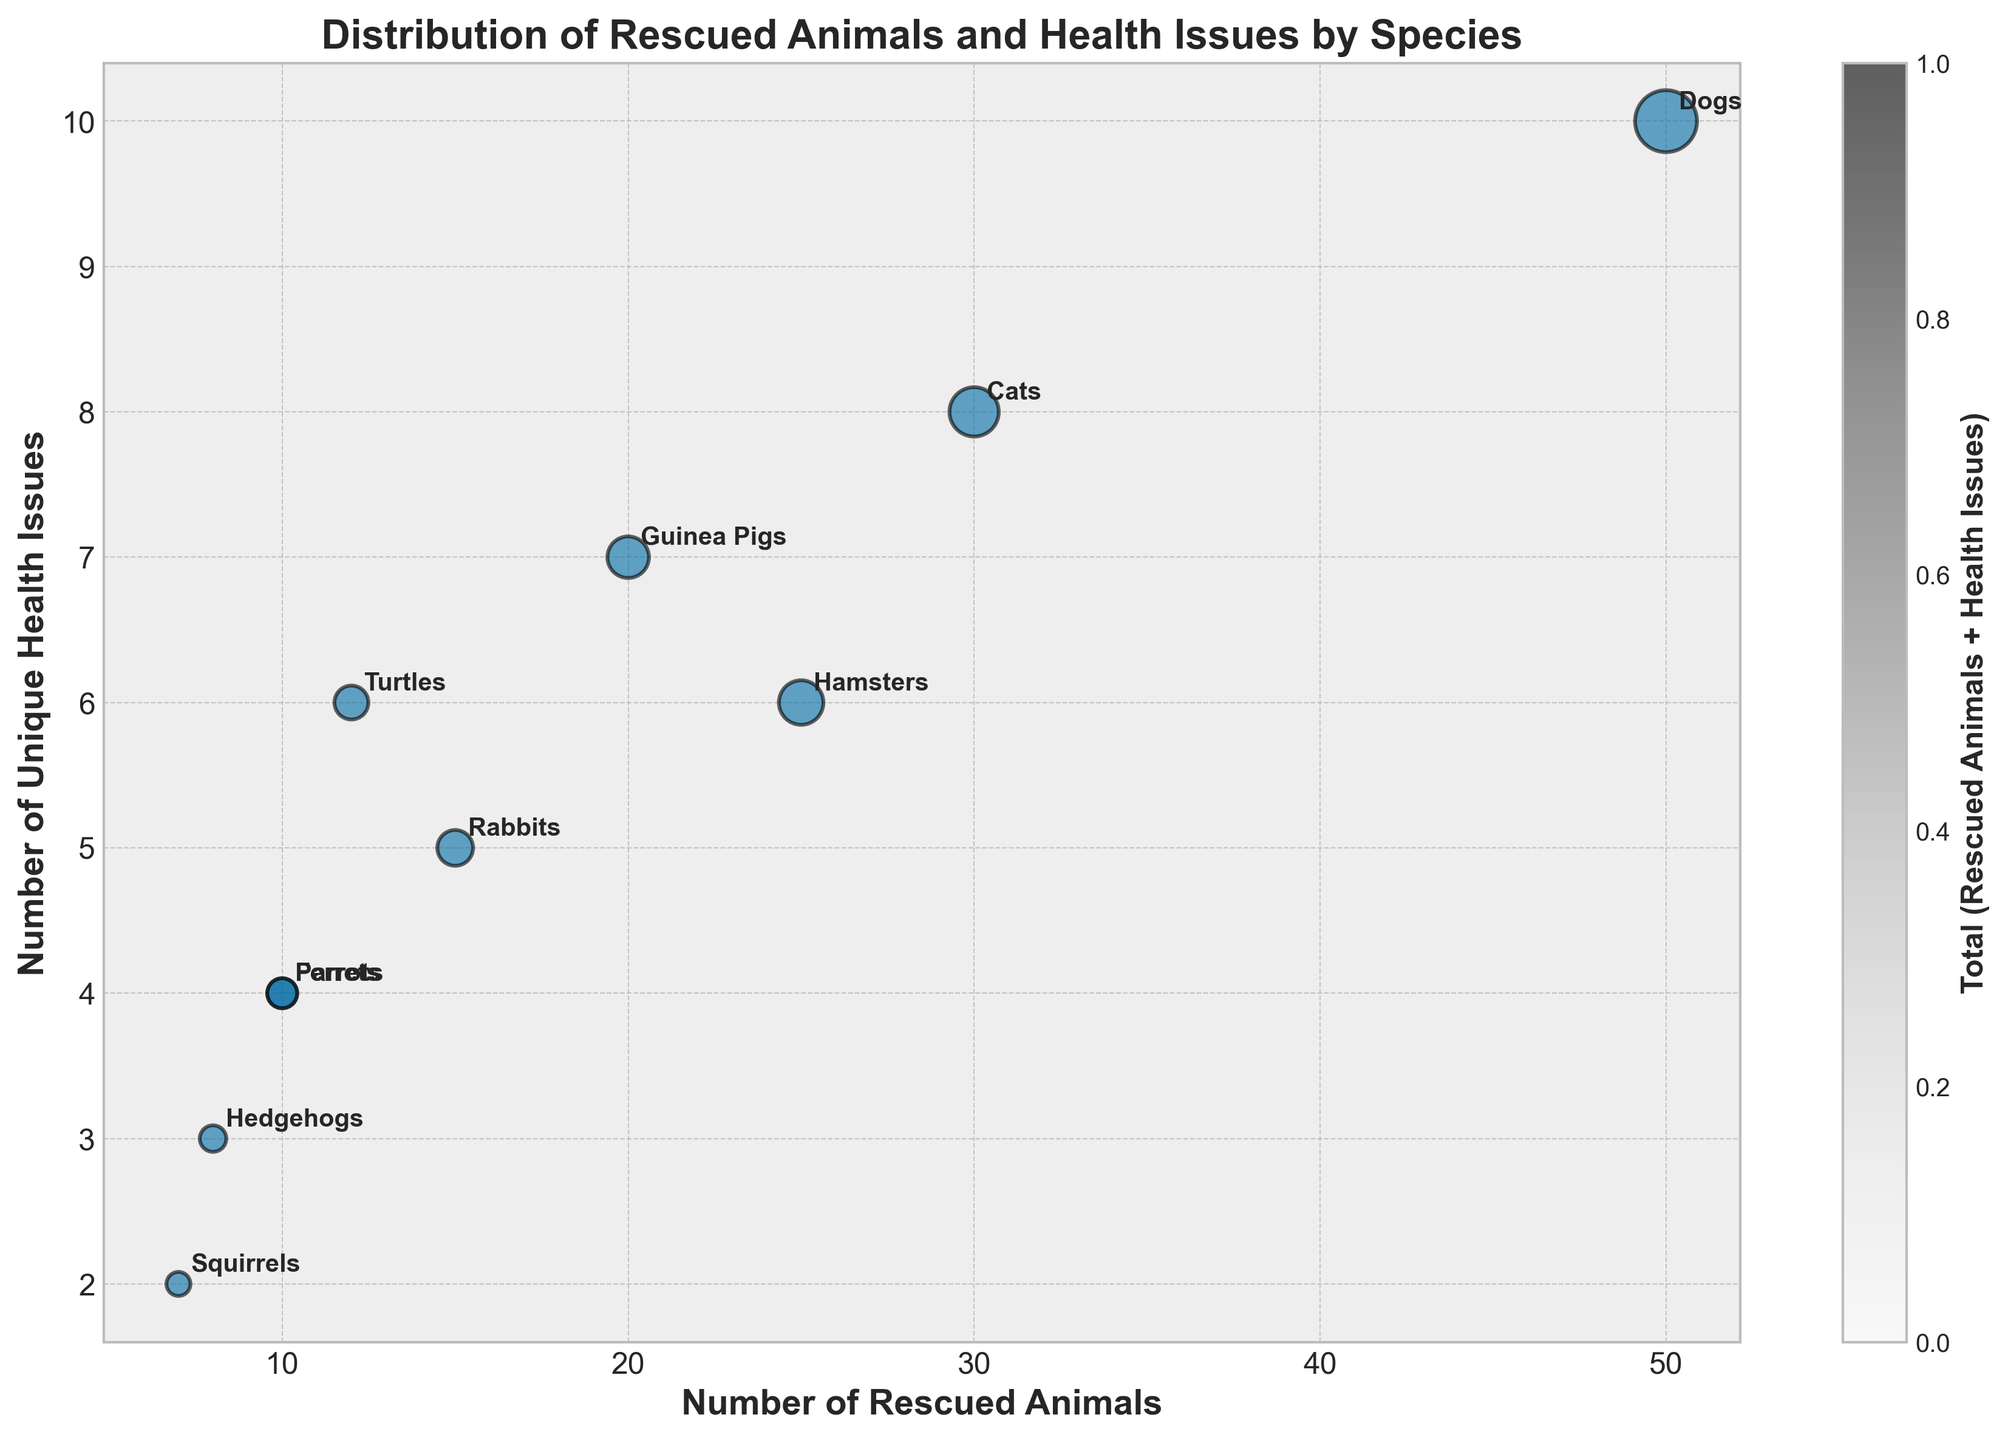How many species of animals are represented in the figure? Count the number of unique species labels annotated on the bubbles.
Answer: 10 Which species has the highest number of rescued animals? Identify the bubble with the highest x-coordinate value and read the corresponding species label.
Answer: Dogs Which species has the lowest number of unique health issues? Identify the bubble with the lowest y-coordinate value and read the corresponding species label.
Answer: Squirrels Which species has a greater number of unique health issues: Parrots or Ferrets? Compare the y-coordinates of the bubbles labeled as Parrots and Ferrets.
Answer: Parrots What's the total number of rescued animals for Dogs and Cats combined? Add the x-coordinate values for Dogs and Cats.
Answer: 80 Which species' bubble appears the smallest in size? Identify the bubble with the smallest visual appearance by comparing all bubble sizes.
Answer: Squirrels What's the difference in the number of unique health issues between the species with the most and least health issues? Identify the species with the highest y-coordinate and the one with the lowest y-coordinate, then subtract the smallest value from the largest value.
Answer: 10 - 2 = 8 Of the animals listed, which species has exactly 6 unique health issues? Locate bubbles on the y-coordinate corresponding to 6 and read species labels.
Answer: Turtles, Hamsters Which species have an equal number of rescued animals? Locate bubbles on the x-coordinate with the same value and read species labels.
Answer: Parrots, Ferrets Which species is closer to having an equal number of rescued animals and unique health issues? Identify species where the x and y-coordinates are more proportional or close in value.
Answer: Turtles 